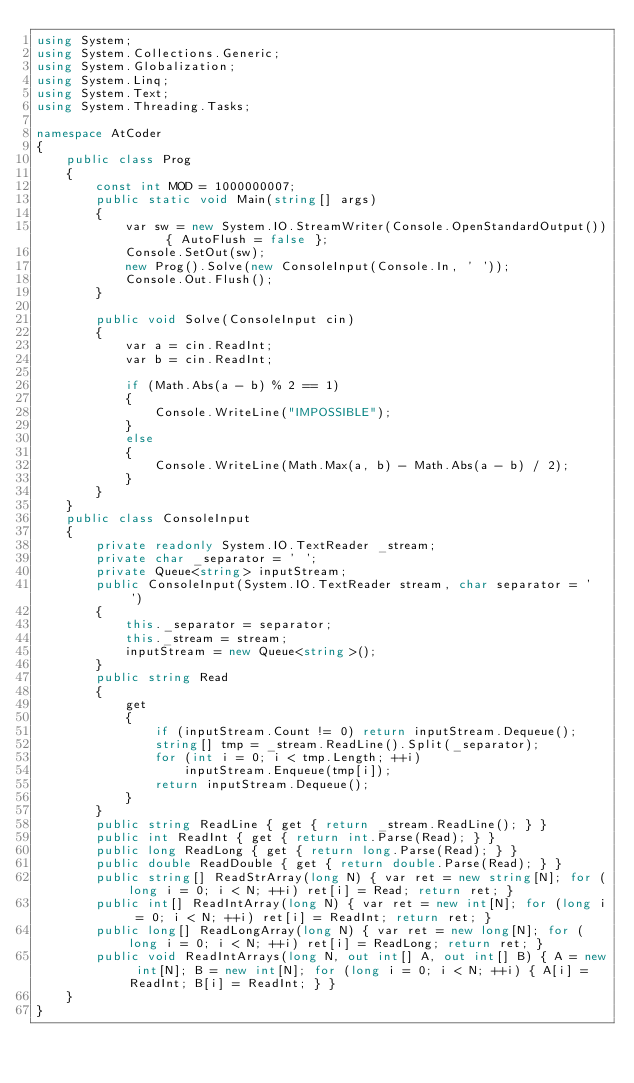<code> <loc_0><loc_0><loc_500><loc_500><_C#_>using System;
using System.Collections.Generic;
using System.Globalization;
using System.Linq;
using System.Text;
using System.Threading.Tasks;

namespace AtCoder
{
    public class Prog
    {
        const int MOD = 1000000007;
        public static void Main(string[] args)
        {
            var sw = new System.IO.StreamWriter(Console.OpenStandardOutput()) { AutoFlush = false };
            Console.SetOut(sw);
            new Prog().Solve(new ConsoleInput(Console.In, ' '));
            Console.Out.Flush();
        }

        public void Solve(ConsoleInput cin)
        {
            var a = cin.ReadInt;
            var b = cin.ReadInt;

            if (Math.Abs(a - b) % 2 == 1)
            {
                Console.WriteLine("IMPOSSIBLE");
            }
            else
            {
                Console.WriteLine(Math.Max(a, b) - Math.Abs(a - b) / 2);
            }
        }
    }
    public class ConsoleInput
    {
        private readonly System.IO.TextReader _stream;
        private char _separator = ' ';
        private Queue<string> inputStream;
        public ConsoleInput(System.IO.TextReader stream, char separator = ' ')
        {
            this._separator = separator;
            this._stream = stream;
            inputStream = new Queue<string>();
        }
        public string Read
        {
            get
            {
                if (inputStream.Count != 0) return inputStream.Dequeue();
                string[] tmp = _stream.ReadLine().Split(_separator);
                for (int i = 0; i < tmp.Length; ++i)
                    inputStream.Enqueue(tmp[i]);
                return inputStream.Dequeue();
            }
        }
        public string ReadLine { get { return _stream.ReadLine(); } }
        public int ReadInt { get { return int.Parse(Read); } }
        public long ReadLong { get { return long.Parse(Read); } }
        public double ReadDouble { get { return double.Parse(Read); } }
        public string[] ReadStrArray(long N) { var ret = new string[N]; for (long i = 0; i < N; ++i) ret[i] = Read; return ret; }
        public int[] ReadIntArray(long N) { var ret = new int[N]; for (long i = 0; i < N; ++i) ret[i] = ReadInt; return ret; }
        public long[] ReadLongArray(long N) { var ret = new long[N]; for (long i = 0; i < N; ++i) ret[i] = ReadLong; return ret; }
        public void ReadIntArrays(long N, out int[] A, out int[] B) { A = new int[N]; B = new int[N]; for (long i = 0; i < N; ++i) { A[i] = ReadInt; B[i] = ReadInt; } }
    }
}
</code> 